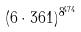Convert formula to latex. <formula><loc_0><loc_0><loc_500><loc_500>( 6 \cdot 3 6 1 ) ^ { 8 ^ { 4 7 4 } }</formula> 